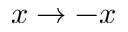<formula> <loc_0><loc_0><loc_500><loc_500>x \to - x</formula> 